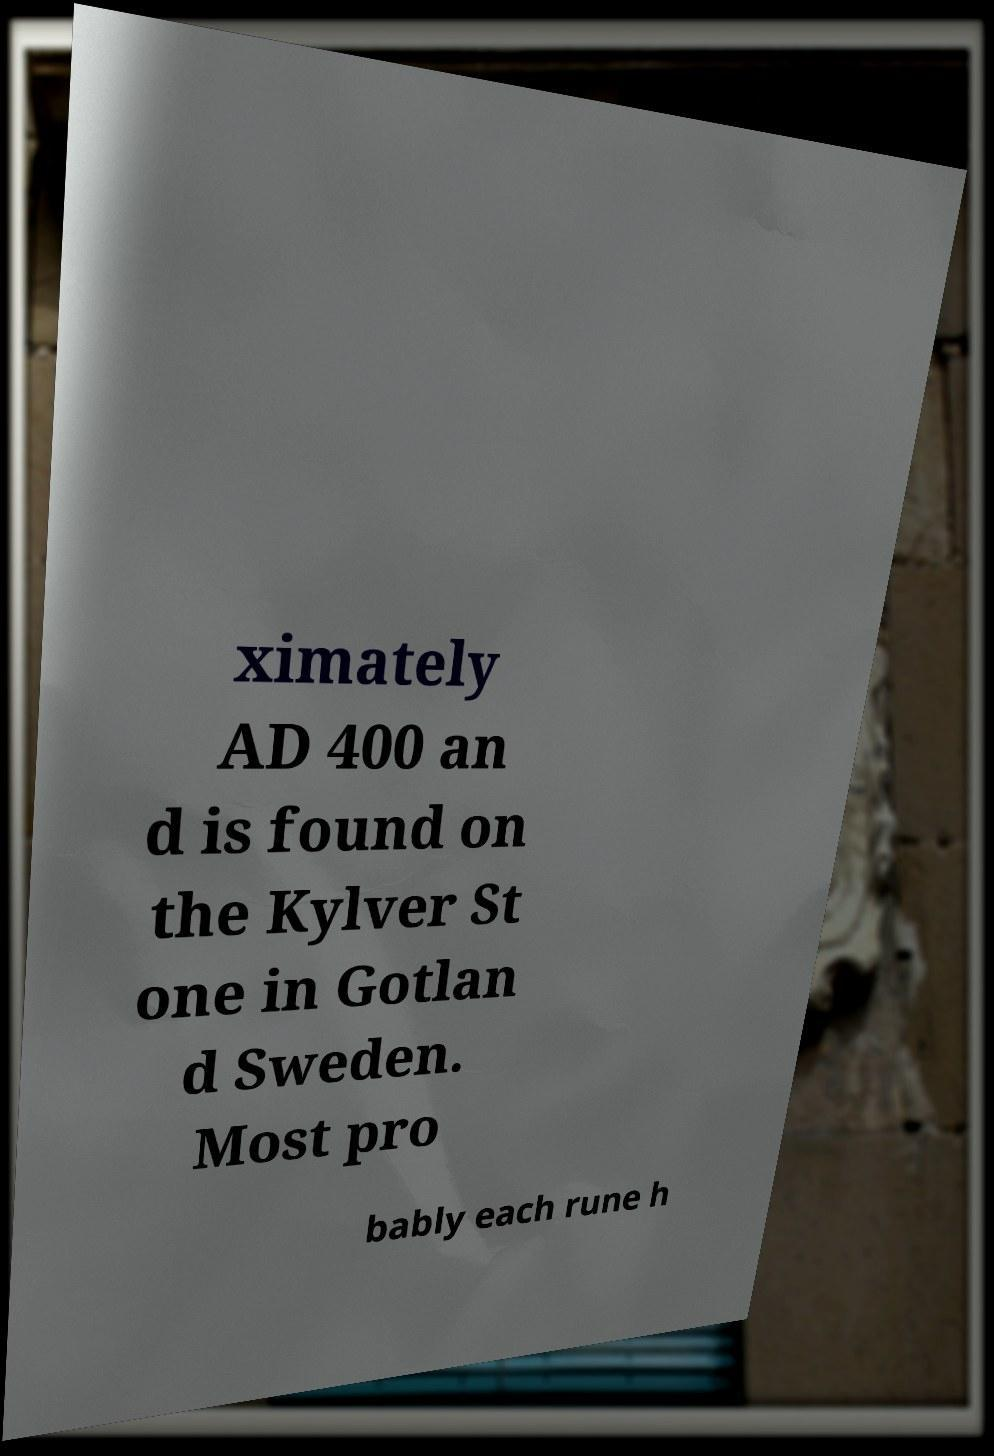Can you accurately transcribe the text from the provided image for me? ximately AD 400 an d is found on the Kylver St one in Gotlan d Sweden. Most pro bably each rune h 